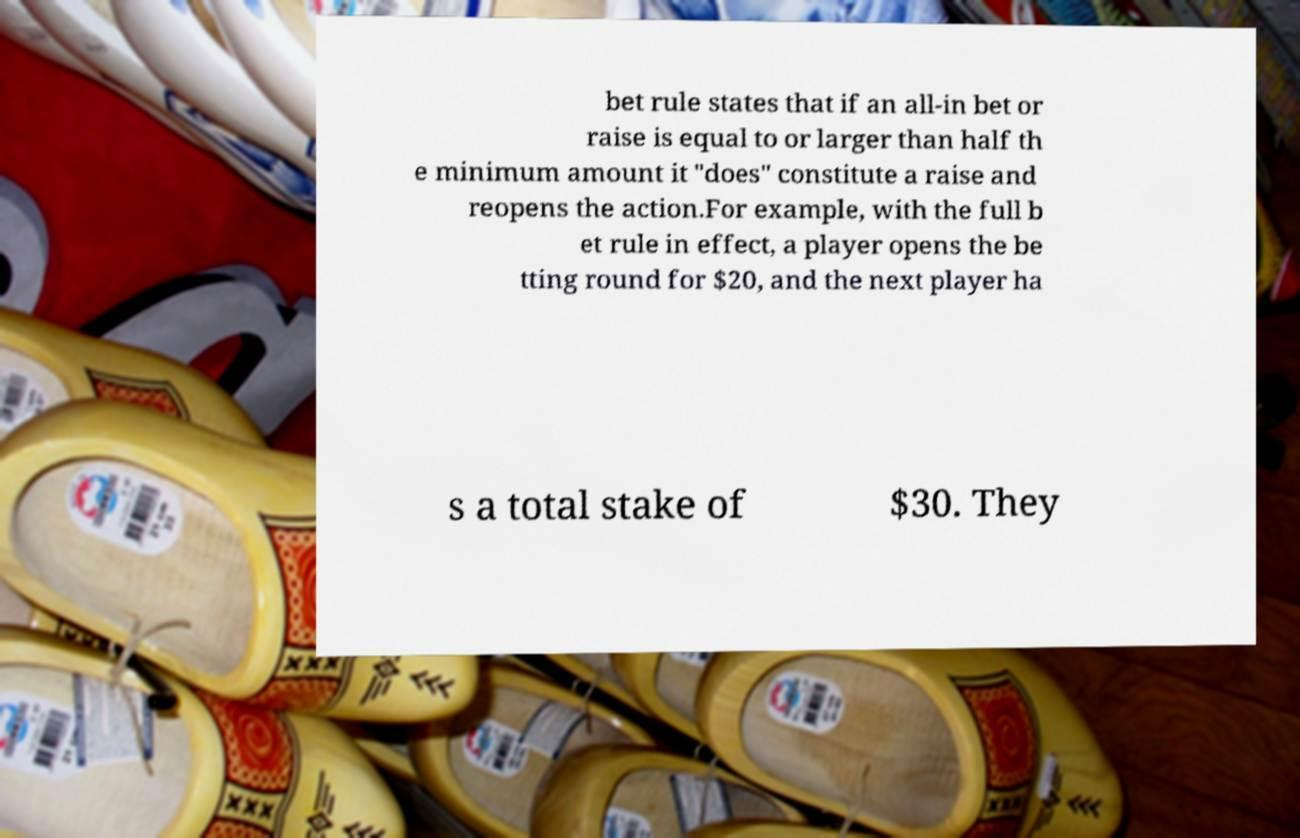Could you extract and type out the text from this image? bet rule states that if an all-in bet or raise is equal to or larger than half th e minimum amount it "does" constitute a raise and reopens the action.For example, with the full b et rule in effect, a player opens the be tting round for $20, and the next player ha s a total stake of $30. They 